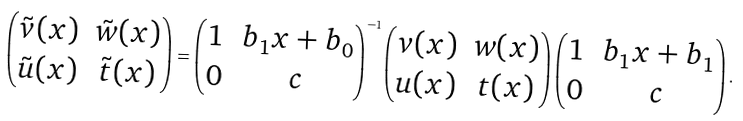<formula> <loc_0><loc_0><loc_500><loc_500>\begin{pmatrix} \tilde { v } ( x ) & \tilde { w } ( x ) \\ \tilde { u } ( x ) & \tilde { t } ( x ) \end{pmatrix} = \begin{pmatrix} 1 & b _ { 1 } x + b _ { 0 } \\ 0 & c \end{pmatrix} ^ { - 1 } \begin{pmatrix} v ( x ) & w ( x ) \\ u ( x ) & t ( x ) \end{pmatrix} \begin{pmatrix} 1 & b _ { 1 } x + b _ { 1 } \\ 0 & c \end{pmatrix} .</formula> 